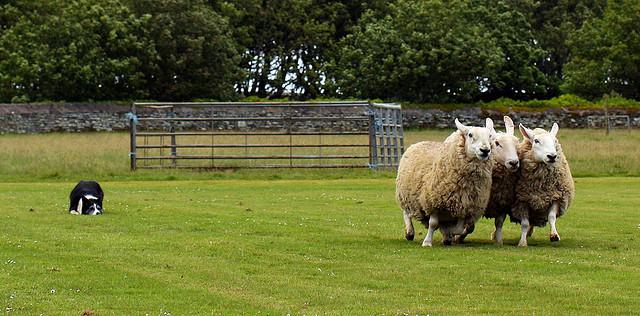Is the dog chasing the sheep?
Give a very brief answer. No. How many sheep are there?
Write a very short answer. 3. What other animal is in the picture?
Be succinct. Dog. 